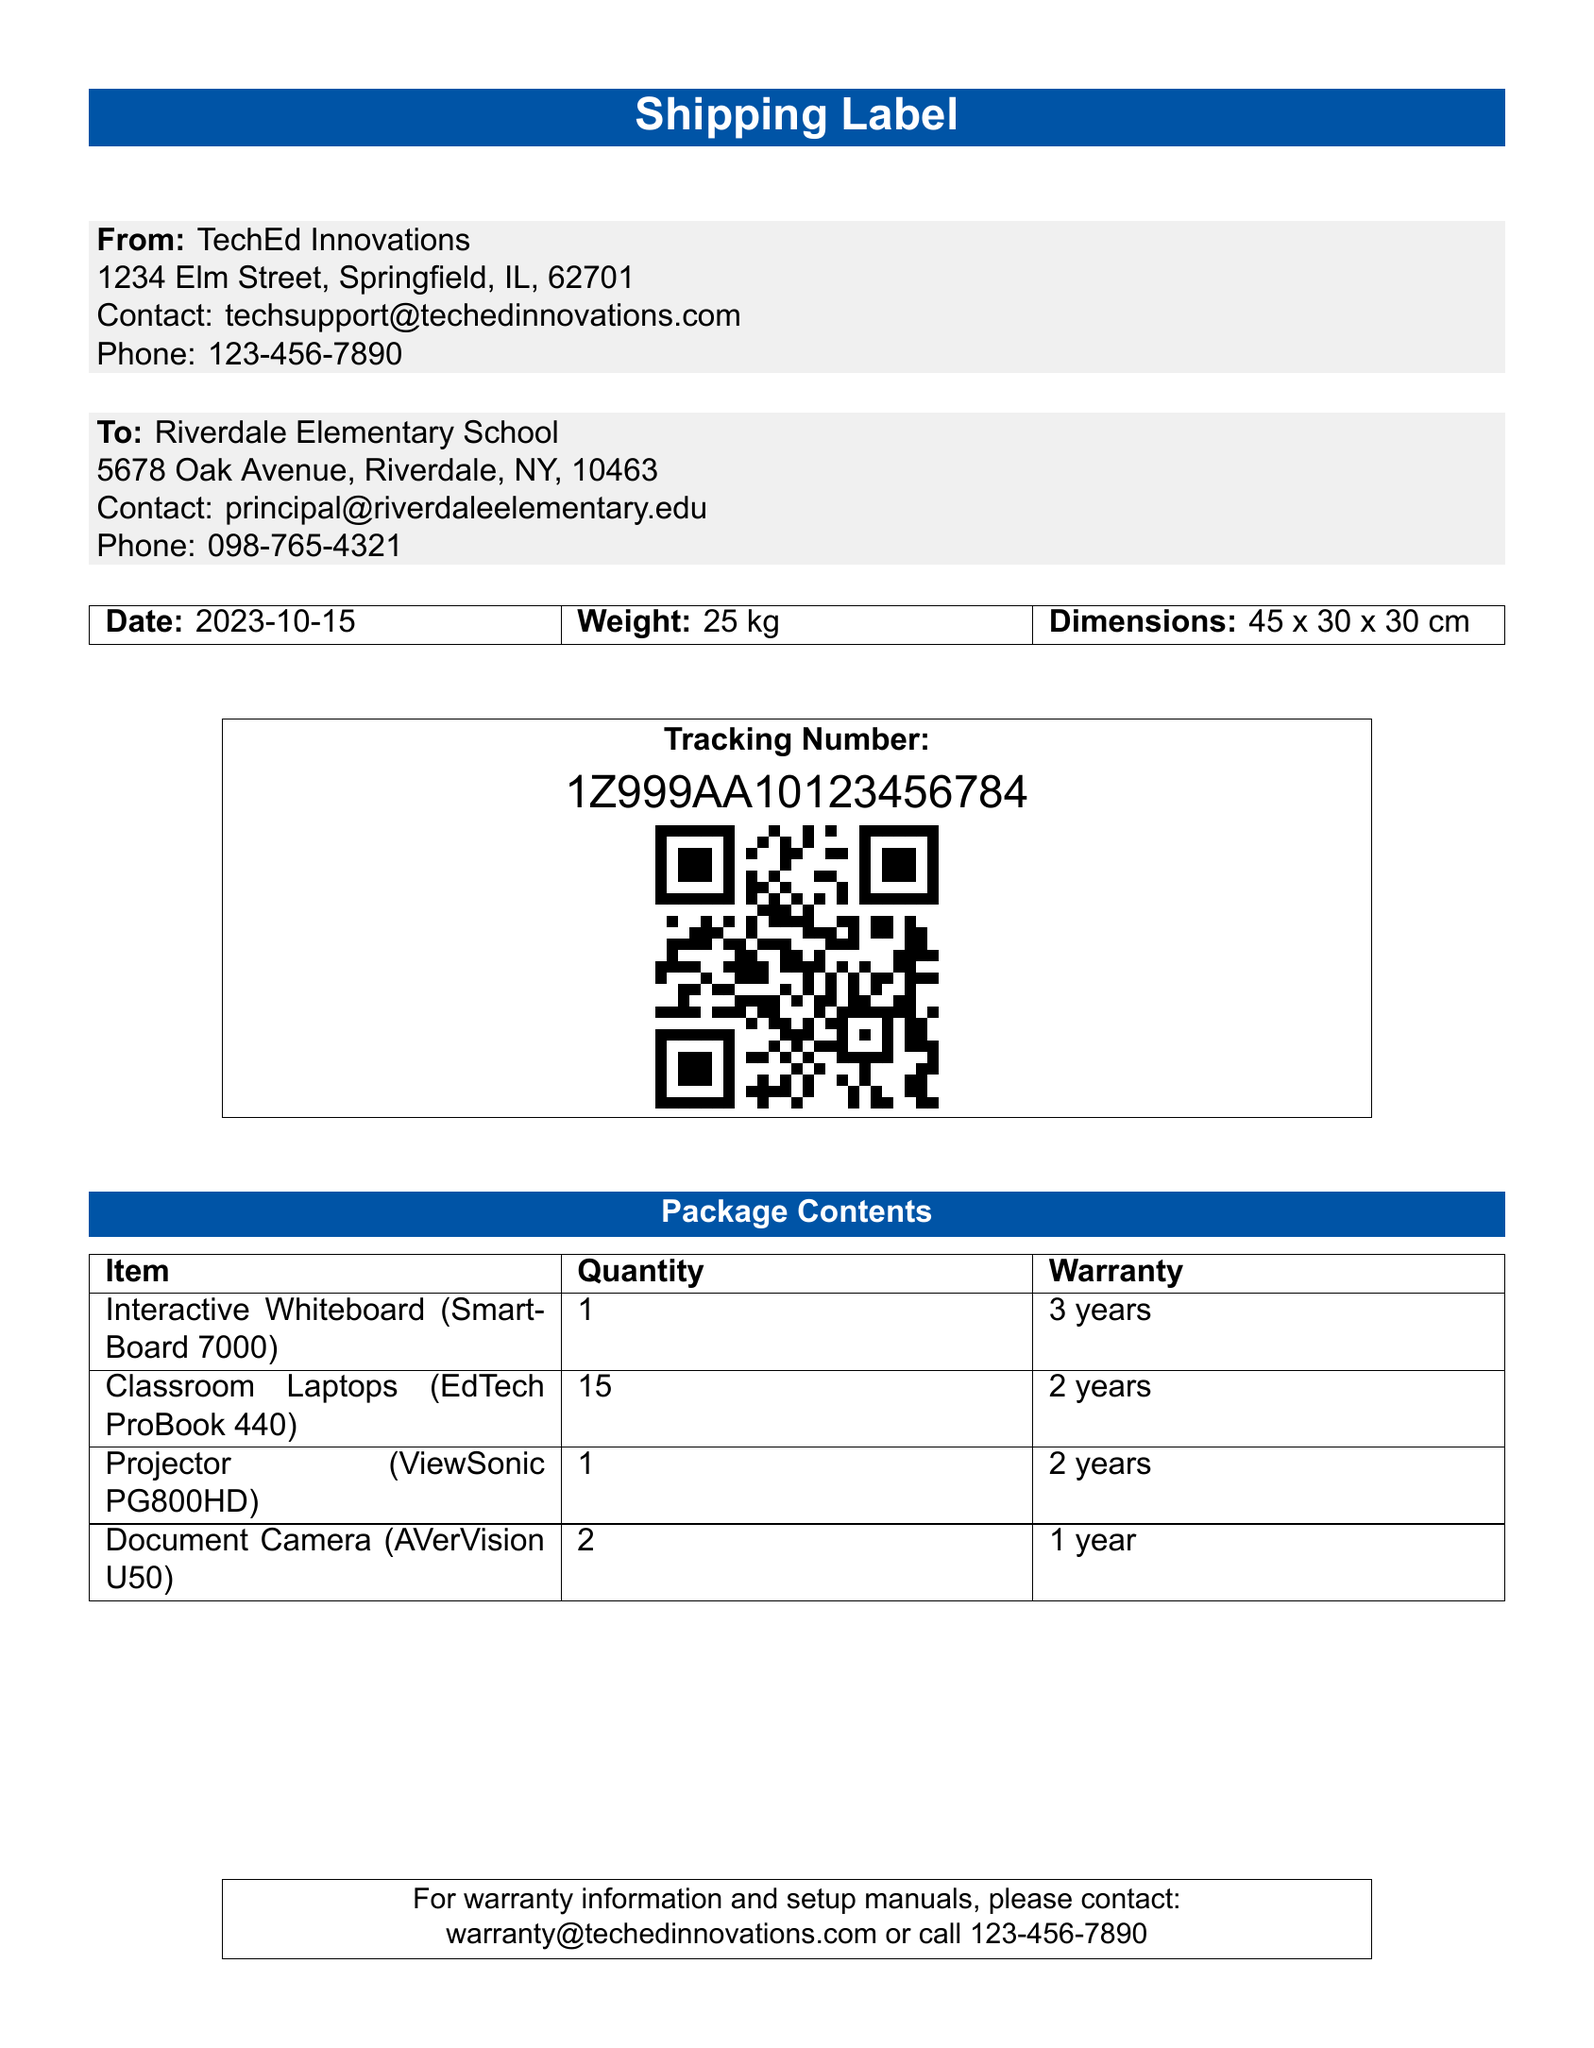What is the sender's name? The sender's name is listed as TechEd Innovations in the document.
Answer: TechEd Innovations What is the weight of the package? The weight is explicitly mentioned in the document under the shipping details.
Answer: 25 kg What is the warranty period for the Interactive Whiteboard? The warranty period can be found in the package contents section for the specified item.
Answer: 3 years How many Classroom Laptops are included in the shipment? The quantity of Classroom Laptops is detailed in the document under package contents.
Answer: 15 What is the tracking number? The tracking number is clearly displayed in the package details section.
Answer: 1Z999AA10123456784 What is the contact email for warranty information? The document provides a specific email address for warranty inquiries.
Answer: warranty@techedinnovations.com What is the delivery date of the items? The delivery date is stated at the top of the shipping label in the document.
Answer: 2023-10-15 How many Document Cameras are included in the shipment? The number of Document Cameras is listed in the package contents section.
Answer: 2 What company's contact phone number is listed? The contact phone number is provided in the sender's information section of the document.
Answer: 123-456-7890 